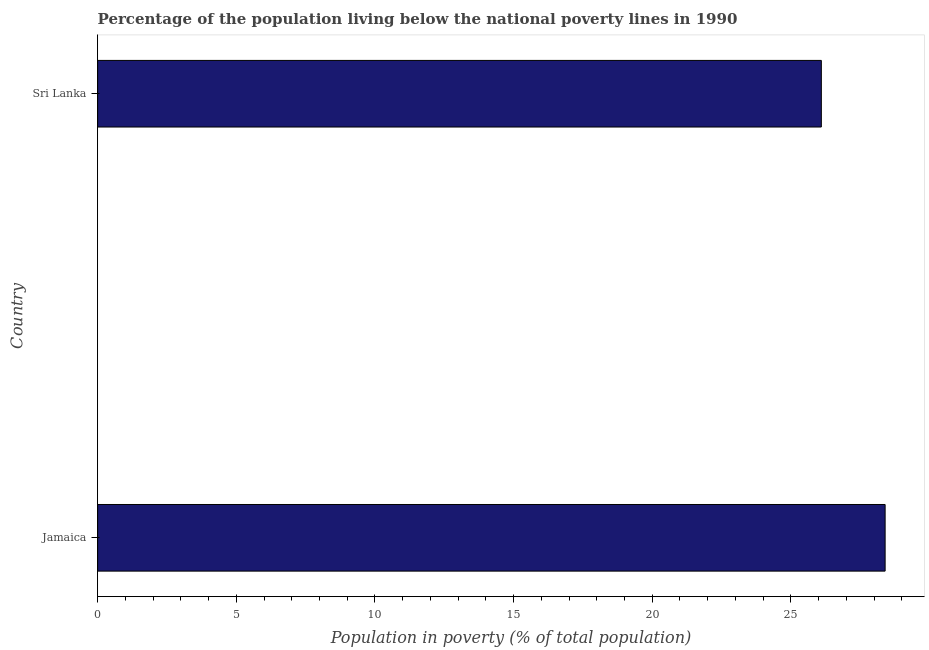Does the graph contain any zero values?
Offer a very short reply. No. Does the graph contain grids?
Your answer should be very brief. No. What is the title of the graph?
Make the answer very short. Percentage of the population living below the national poverty lines in 1990. What is the label or title of the X-axis?
Make the answer very short. Population in poverty (% of total population). What is the label or title of the Y-axis?
Your answer should be compact. Country. What is the percentage of population living below poverty line in Jamaica?
Give a very brief answer. 28.4. Across all countries, what is the maximum percentage of population living below poverty line?
Provide a short and direct response. 28.4. Across all countries, what is the minimum percentage of population living below poverty line?
Offer a terse response. 26.1. In which country was the percentage of population living below poverty line maximum?
Your answer should be compact. Jamaica. In which country was the percentage of population living below poverty line minimum?
Your answer should be very brief. Sri Lanka. What is the sum of the percentage of population living below poverty line?
Your answer should be compact. 54.5. What is the average percentage of population living below poverty line per country?
Ensure brevity in your answer.  27.25. What is the median percentage of population living below poverty line?
Offer a very short reply. 27.25. In how many countries, is the percentage of population living below poverty line greater than 12 %?
Your response must be concise. 2. What is the ratio of the percentage of population living below poverty line in Jamaica to that in Sri Lanka?
Your response must be concise. 1.09. How many countries are there in the graph?
Keep it short and to the point. 2. What is the difference between two consecutive major ticks on the X-axis?
Your answer should be very brief. 5. What is the Population in poverty (% of total population) in Jamaica?
Provide a succinct answer. 28.4. What is the Population in poverty (% of total population) of Sri Lanka?
Keep it short and to the point. 26.1. What is the difference between the Population in poverty (% of total population) in Jamaica and Sri Lanka?
Keep it short and to the point. 2.3. What is the ratio of the Population in poverty (% of total population) in Jamaica to that in Sri Lanka?
Keep it short and to the point. 1.09. 